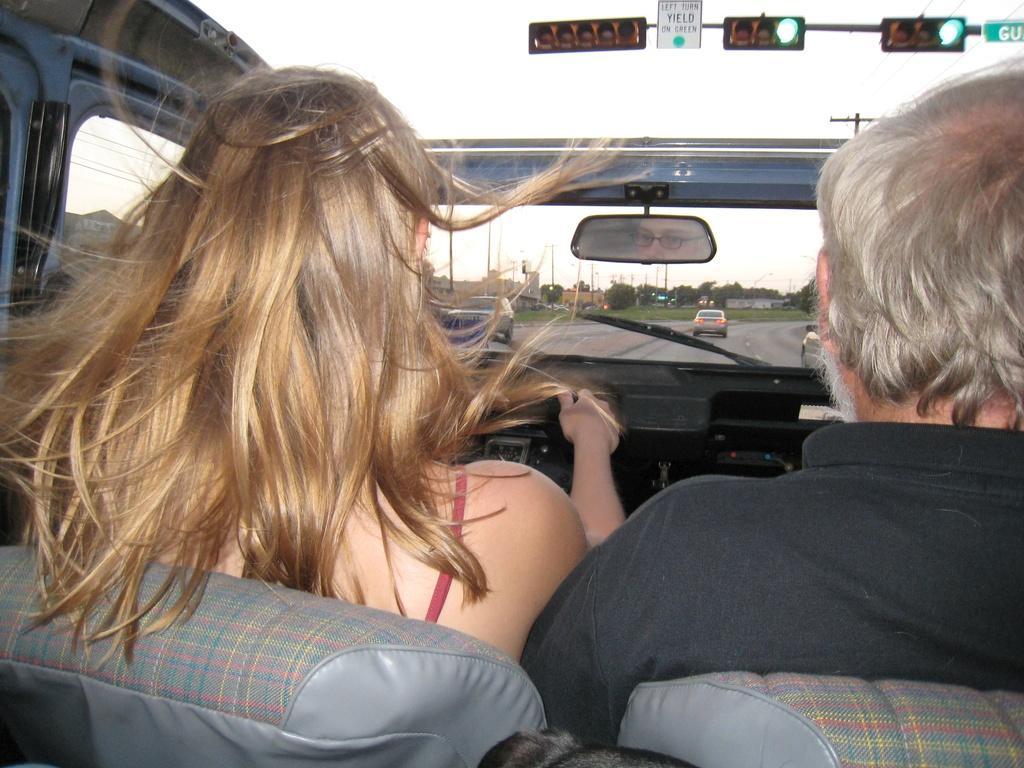Describe this image in one or two sentences. This is the picture taken in the outdoor, there are two person sitting on a car and riding on a road. In front of the people there are trees, building, sky and traffic lights. 